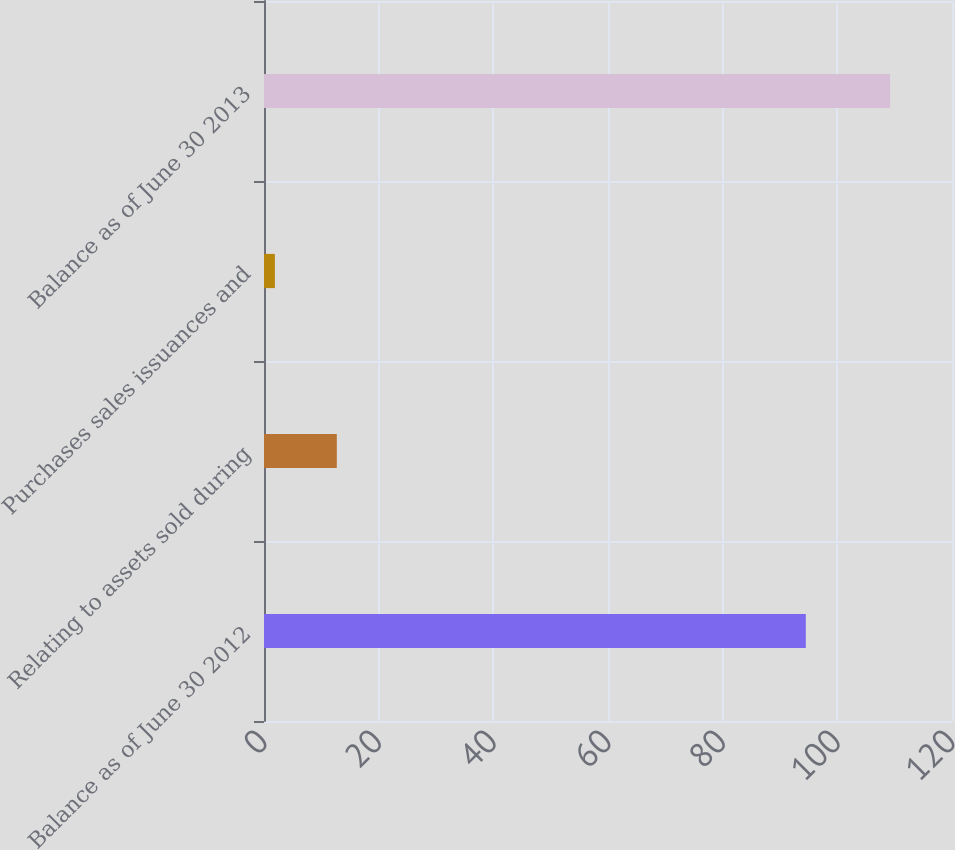Convert chart to OTSL. <chart><loc_0><loc_0><loc_500><loc_500><bar_chart><fcel>Balance as of June 30 2012<fcel>Relating to assets sold during<fcel>Purchases sales issuances and<fcel>Balance as of June 30 2013<nl><fcel>94.5<fcel>12.7<fcel>1.9<fcel>109.2<nl></chart> 